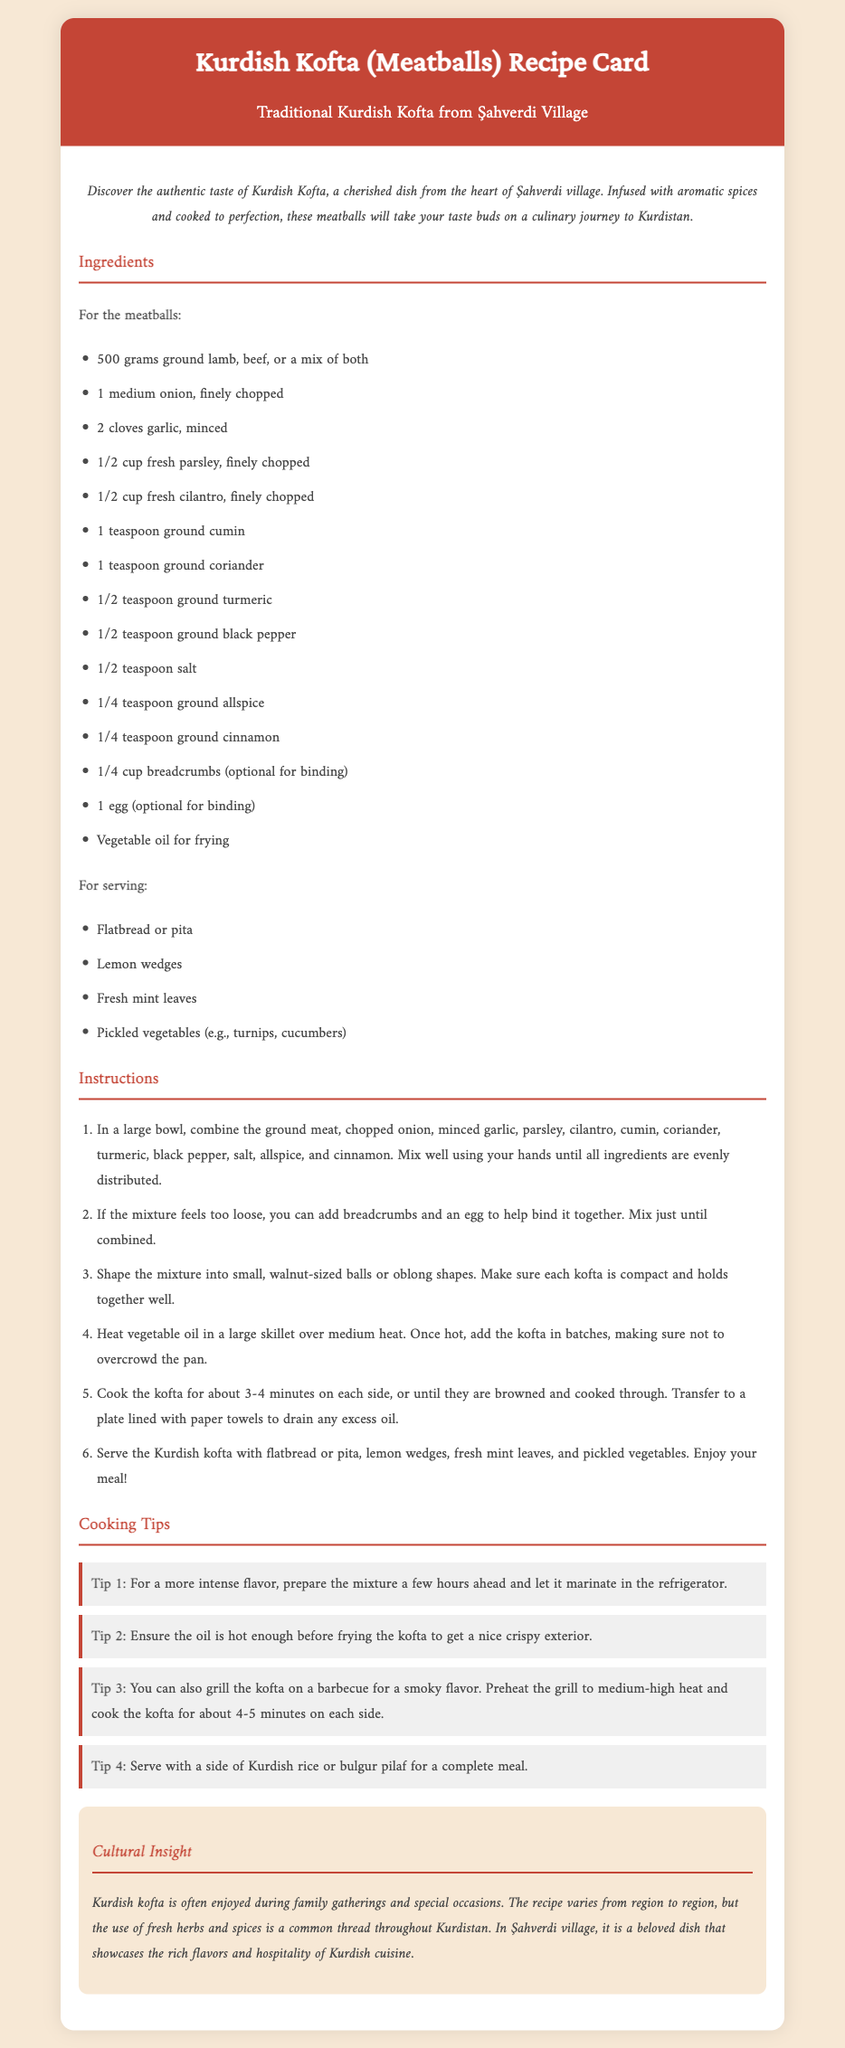what is the main ingredient for the kofta? The main ingredient for the kofta is ground lamb, beef, or a mix of both, as listed in the ingredients section.
Answer: ground lamb, beef, or a mix of both how long should kofta be cooked on each side? The cooking time for the kofta on each side is provided in the instructions.
Answer: 3-4 minutes which herbs are included in the kofta recipe? The ingredients list mentions specific herbs used in the kofta mixture.
Answer: parsley, cilantro what is optional for binding the meatball mixture? The instructions indicate ingredients that can help bind the kofta mixture if needed.
Answer: breadcrumbs and egg how is the kofta commonly served? The serving suggestions direct users to specific items to accompany the kofta.
Answer: flatbread or pita what can enhance the flavor of the kofta mixture? One of the cooking tips describes a method to increase the flavor intensity of the kofta.
Answer: marinate in the refrigerator what color is the header background? The document states the background color of the header, reflecting its visual design.
Answer: #c44536 during what type of occasions is kofta traditionally enjoyed? The cultural insight discusses the typical occasions associated with kofta.
Answer: family gatherings and special occasions 